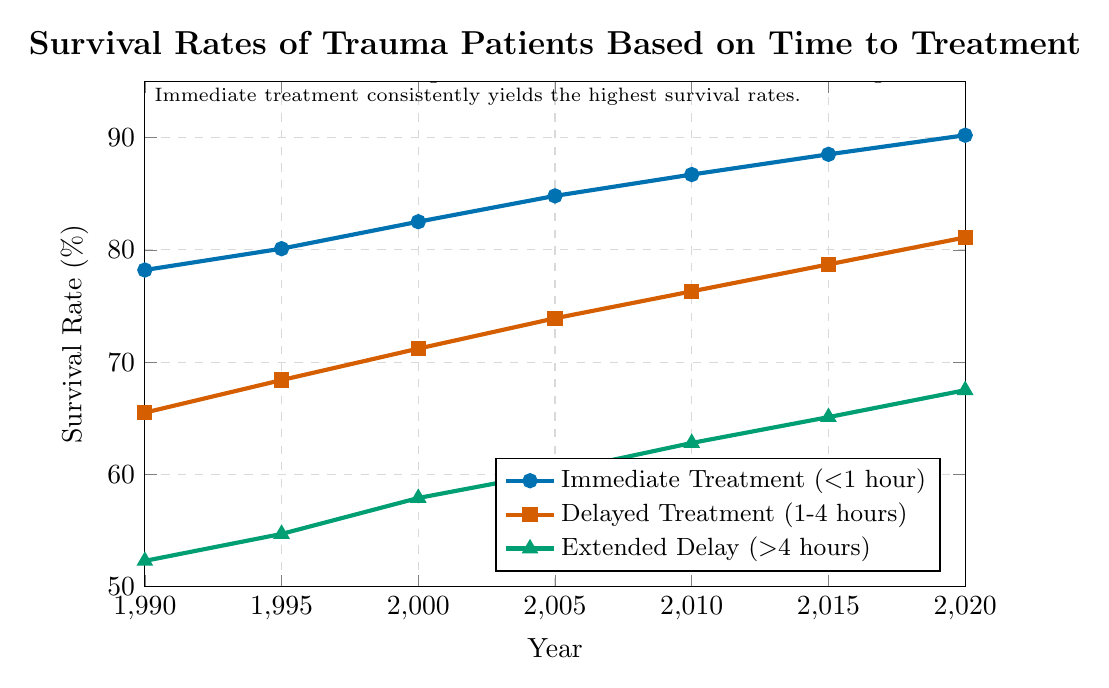What is the survival rate for Immediate Treatment in 2020? Check the "Immediate Treatment (<1 hour)" line for the year 2020. The value is 90.2%.
Answer: 90.2% Which category had the lowest survival rate in 1995? Compare the survival rates for all three categories in 1995. Immediate Treatment is 80.1%, Delayed Treatment is 68.4%, and Extended Delay is 54.7%. The lowest is Extended Delay.
Answer: Extended Delay What is the difference in survival rates between Immediate Treatment and Extended Delay in 2010? For 2010, the Immediate Treatment rate is 86.7%, and the Extended Delay rate is 62.8%. Subtract the Extended Delay rate from the Immediate Treatment rate: 86.7% - 62.8% = 23.9%.
Answer: 23.9% Between which consecutive years did Delayed Treatment see the greatest increase in survival rate? Calculate the increase for each period: 1990-1995 (68.4% - 65.5% = 2.9%), 1995-2000 (71.2% - 68.4% = 2.8%), 2000-2005 (73.9% - 71.2% = 2.7%), 2005-2010 (76.3% - 73.9% = 2.4%), 2010-2015 (78.7% - 76.3% = 2.4%), 2015-2020 (81.1% - 78.7% = 2.4%). The greatest increase is from 1990 to 1995.
Answer: 1990 to 1995 What is the average survival rate for Extended Delay over the displayed period? Sum the survival rates for Extended Delay from 1990 to 2020 and divide by the number of years: (52.3 + 54.7 + 57.9 + 60.2 + 62.8 + 65.1 + 67.5) / 7 = 60.07%.
Answer: 60.07% Is the survival rate increase for Immediate Treatment from 1990 to 2020 larger than that for Delayed Treatment? Calculate the increase for both categories: Immediate Treatment (90.2% - 78.2% = 12%), Delayed Treatment (81.1% - 65.5% = 15.6%). The increase is larger for Delayed Treatment.
Answer: No How much higher was the survival rate for Immediate Treatment compared to Delayed Treatment in 2005? For 2005, the survival rate for Immediate Treatment is 84.8% and for Delayed Treatment is 73.9%. The difference is 84.8% - 73.9% = 10.9%.
Answer: 10.9% Which year saw Extended Delay's survival rate cross 60%? Looking at the Extended Delay line, the survival rate crosses 60% between 2000 and 2005, specifically in 2005.
Answer: 2005 What is the progression of the survival rate for Extended Delay from 1990 to 2020? Observe the trend in the Extended Delay line: The survival rate increases steadily from 52.3% in 1990 to 67.5% in 2020.
Answer: Steady increase Considering all categories, which year shows the highest overall improvement compared to the previous year? Compare year-over-year improvements across all categories, 1995 shows significant improvements: Immediate Treatment (80.1% - 78.2% = 1.9%), Delayed Treatment (68.4% - 65.5% = 2.9%), Extended Delay (54.7% - 52.3% = 2.4%). Delayed Treatment improvement from 1990 to 1995 is the greatest (2.9%).
Answer: 1995 